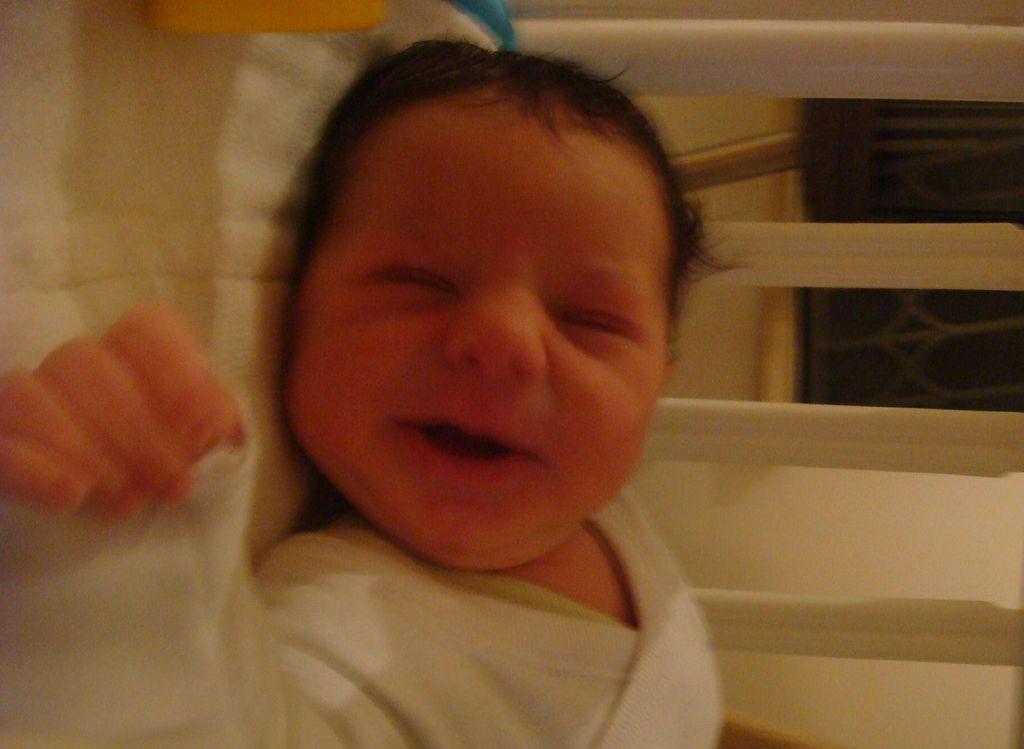Describe this image in one or two sentences. In this image a baby is lying on a bed. These are wooden fence. In the background there is a window. 